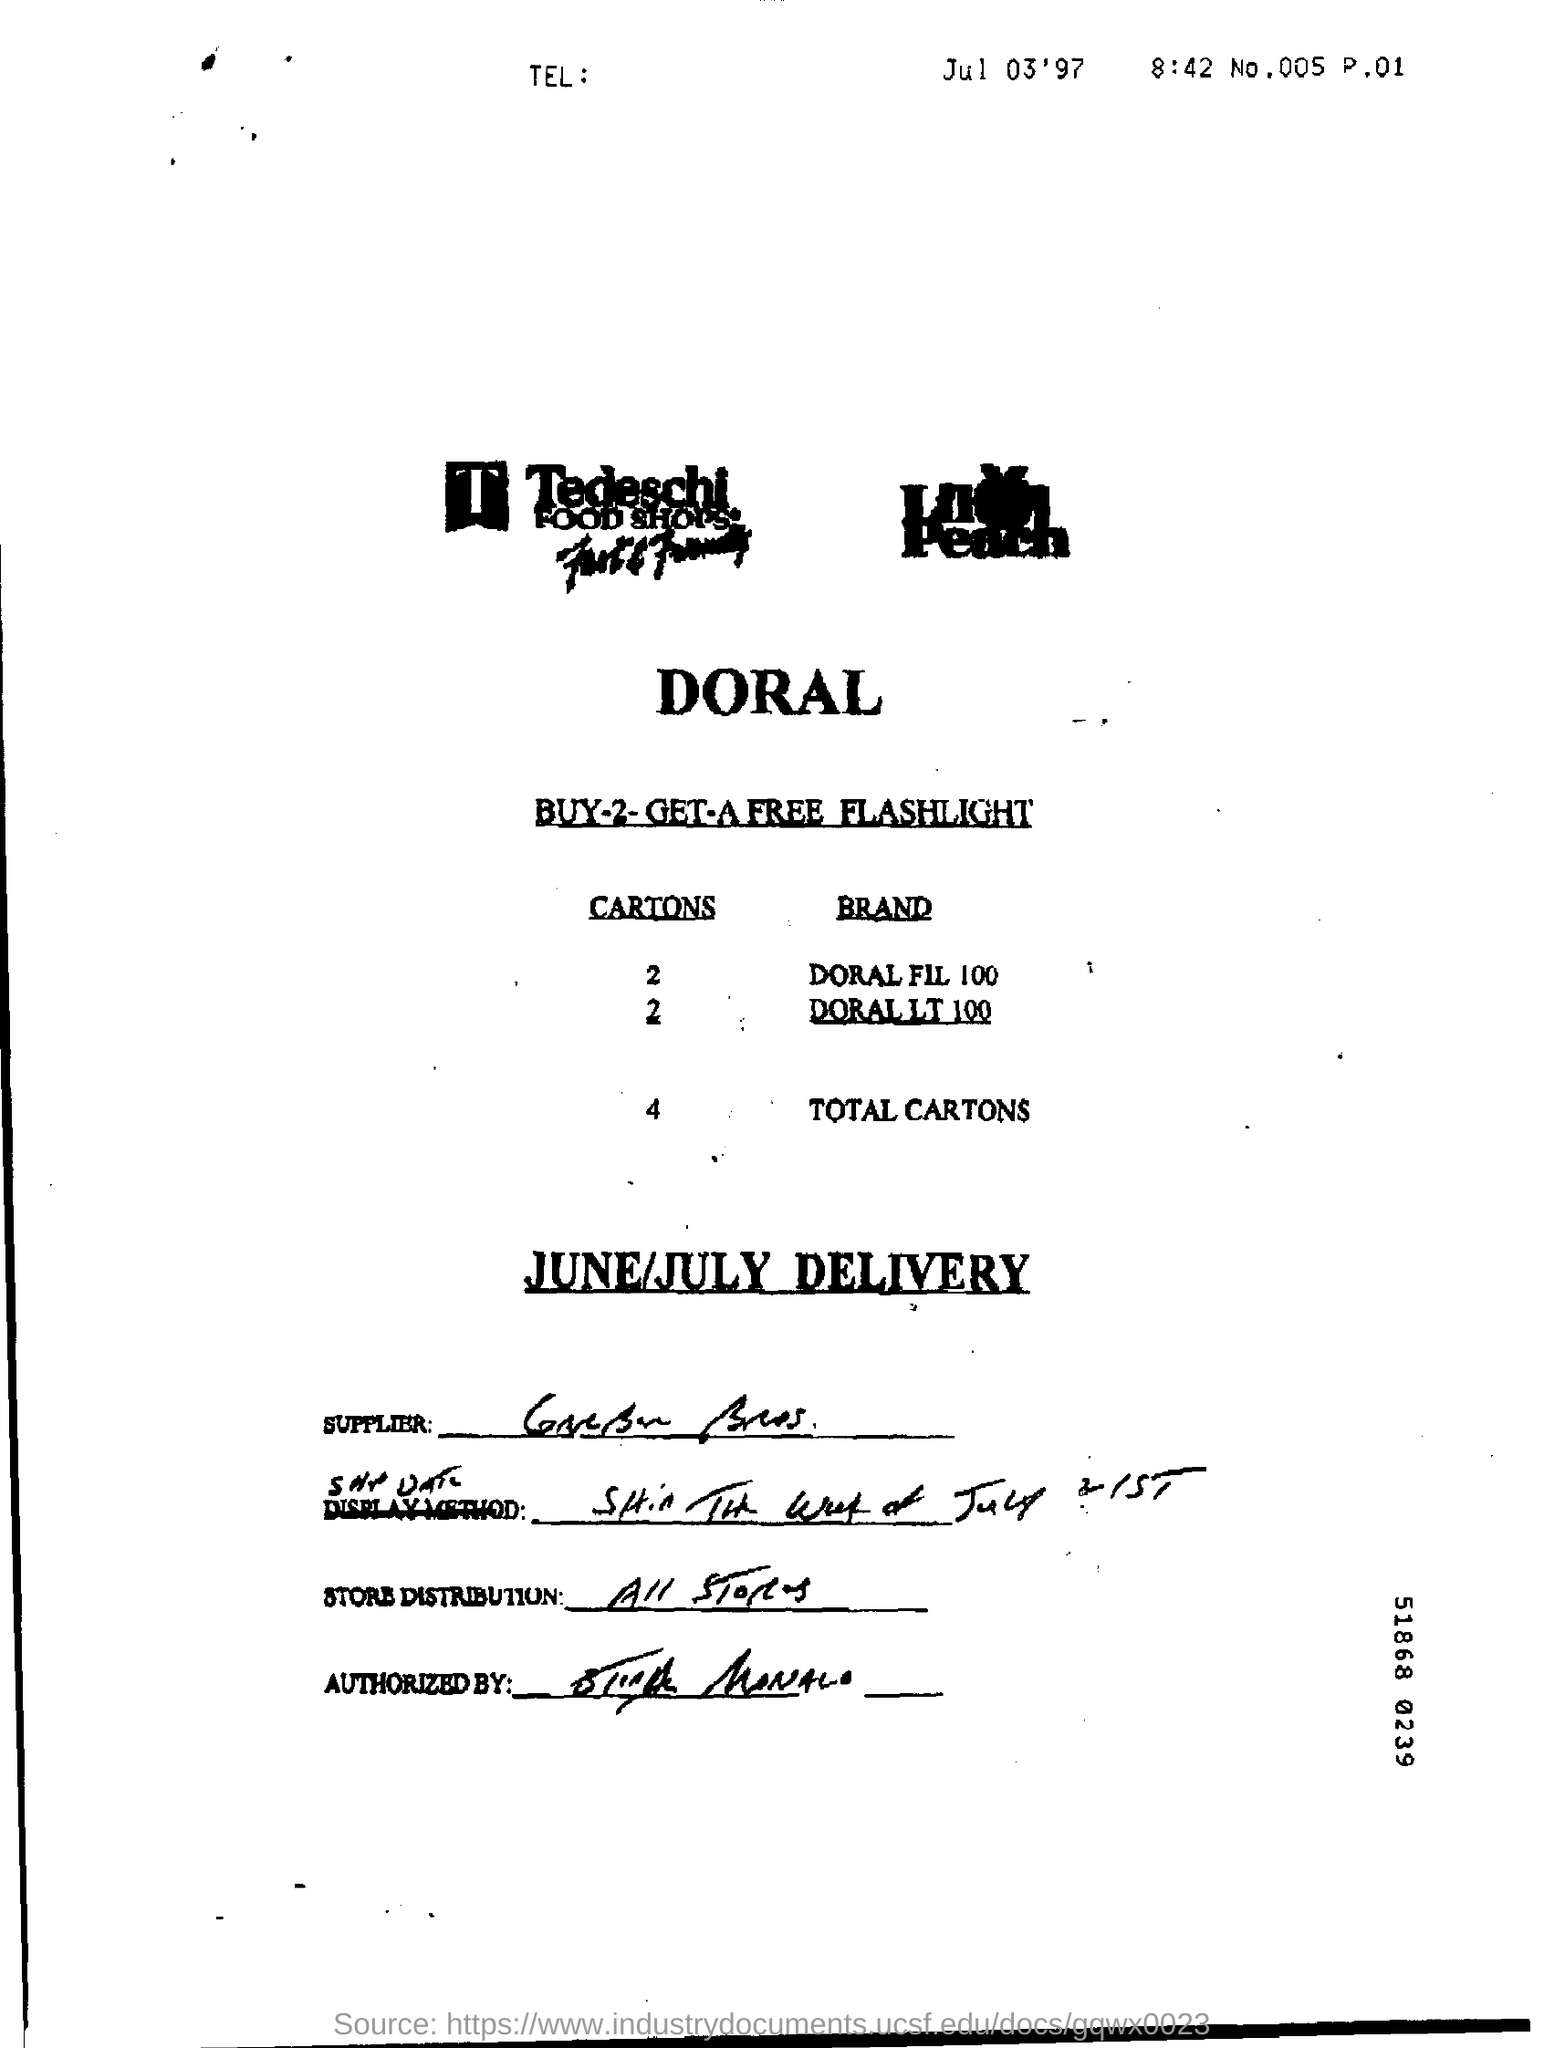Draw attention to some important aspects in this diagram. There are a total of 4 cartons of both Doral FIL 100 and Doral LT 100. 